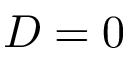Convert formula to latex. <formula><loc_0><loc_0><loc_500><loc_500>D = 0</formula> 